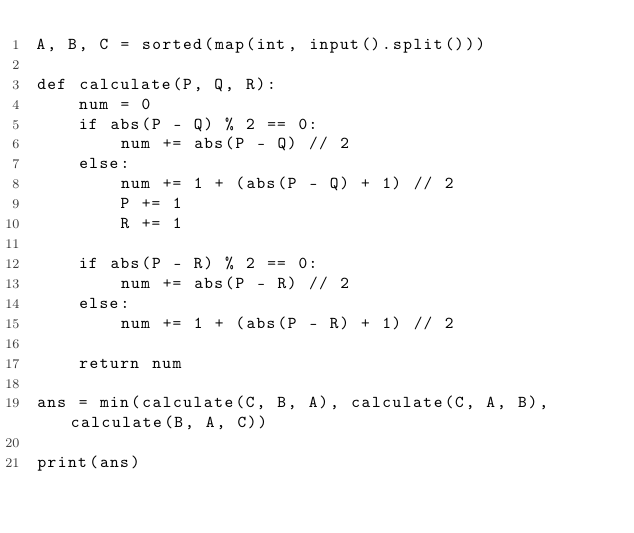Convert code to text. <code><loc_0><loc_0><loc_500><loc_500><_Python_>A, B, C = sorted(map(int, input().split()))

def calculate(P, Q, R):
    num = 0
    if abs(P - Q) % 2 == 0:
        num += abs(P - Q) // 2
    else:
        num += 1 + (abs(P - Q) + 1) // 2
        P += 1
        R += 1

    if abs(P - R) % 2 == 0:
        num += abs(P - R) // 2
    else:
        num += 1 + (abs(P - R) + 1) // 2

    return num

ans = min(calculate(C, B, A), calculate(C, A, B), calculate(B, A, C))

print(ans)</code> 